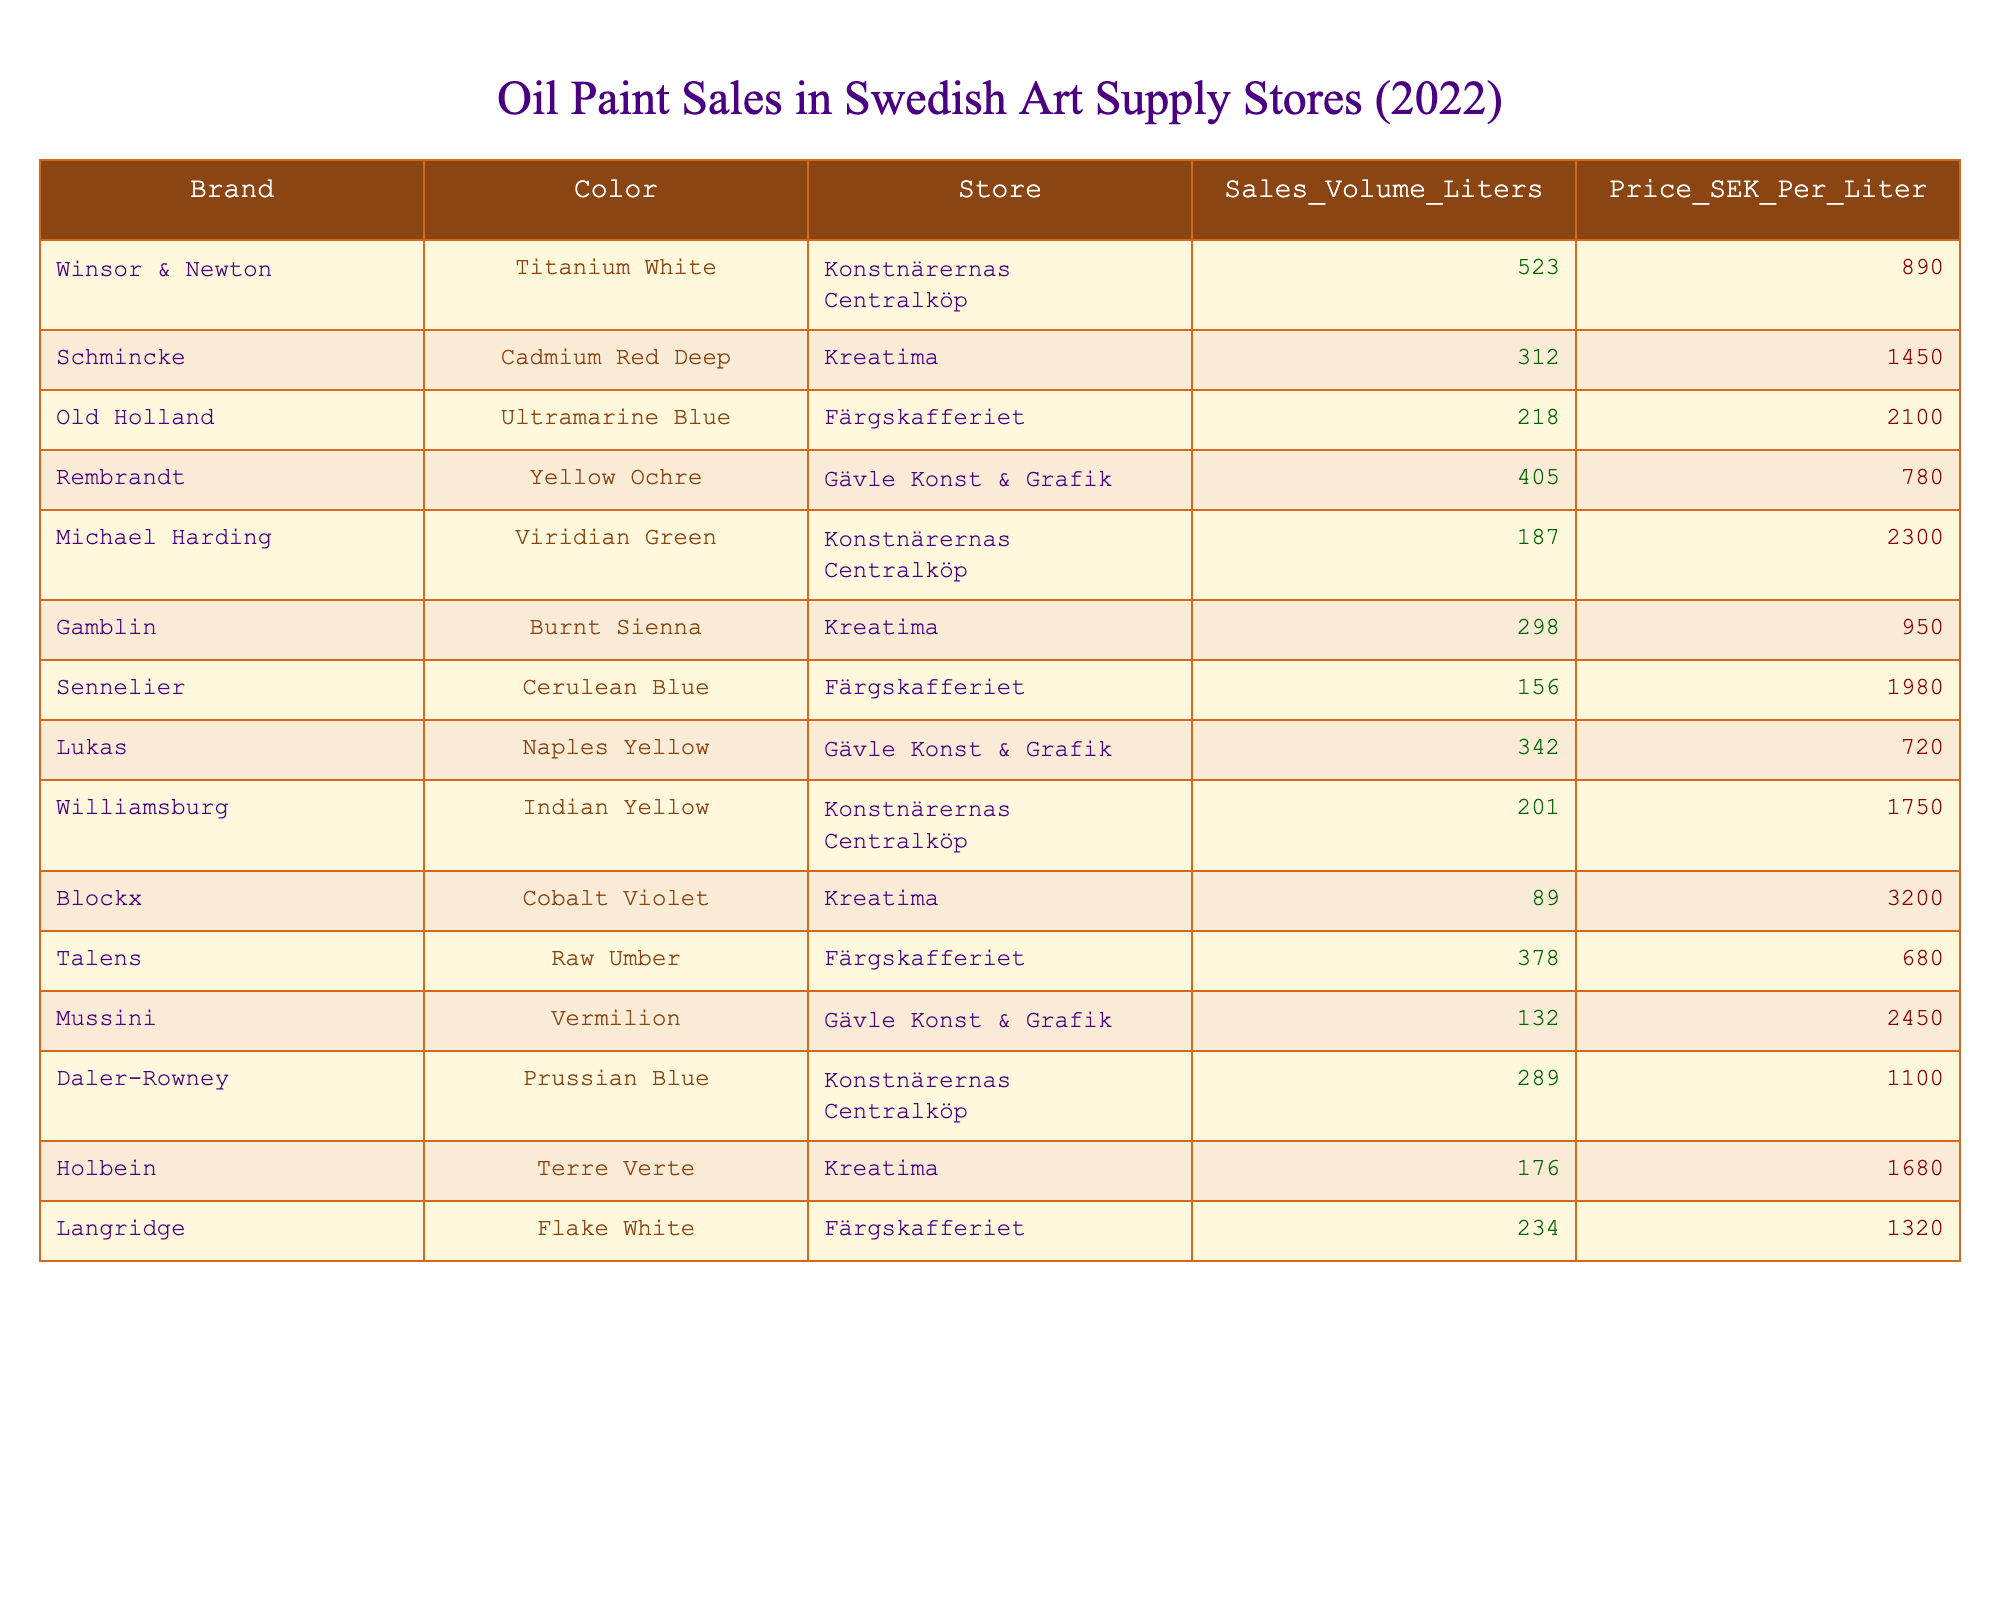What brand sold the highest volume of oil paint? Looking at the sales volume column, Winsor & Newton has the highest sales volume at 523 liters.
Answer: Winsor & Newton What is the price per liter of Schmincke Cadmium Red Deep? The price per liter for Schmincke Cadmium Red Deep, as seen in the price column next to this color, is 1450 SEK.
Answer: 1450 SEK Which color has the lowest sales volume? By scanning the sales volume column, Blockx Cobalt Violet shows the lowest sales volume with 89 liters sold.
Answer: Blockx Cobalt Violet What is the total sales volume for all colors sold by Konstnärernas Centralköp? The sales volumes for Konstnärernas Centralköp are 523, 187, 201, and 289 liters. Adding them up: 523 + 187 + 201 + 289 = 1200 liters.
Answer: 1200 liters Is the price per liter for Talens Raw Umber lower than that for Holbein Terre Verte? Talens Raw Umber is priced at 680 SEK per liter while Holbein Terre Verte is at 1680 SEK per liter, so Talens Raw Umber's price is lower than that of Holbein Terre Verte.
Answer: Yes What is the average price per liter of oil paints sold at Gävle Konst & Grafik? The prices at Gävle Konst & Grafik are 780 SEK (Yellow Ochre), 720 SEK (Naples Yellow), and 2450 SEK (Vermilion). To find the average, sum them: 780 + 720 + 2450 = 3950 SEK, then divide by 3, resulting in an average of 1316.67 SEK.
Answer: 1316.67 SEK Which store sold the highest total volume of oil paints? To find this, sum the sales volumes for each store: Konstnärernas Centralköp - 523 + 187 + 201 + 289 = 1200; Kreatima - 312 + 298 + 89 + 176 = 875; Färgskafferiet - 218 + 405 + 156 + 378 = 1157; Gävle Konst & Grafik - 405 + 342 + 132 = 879. The highest total is at Konstnärernas Centralköp with 1200 liters.
Answer: Konstnärernas Centralköp What is the difference in sales volume between the highest and the lowest selling oil paint? The highest sold is Winsor & Newton with 523 liters and the lowest is Blockx with 89 liters. The difference is 523 - 89 = 434 liters.
Answer: 434 liters 